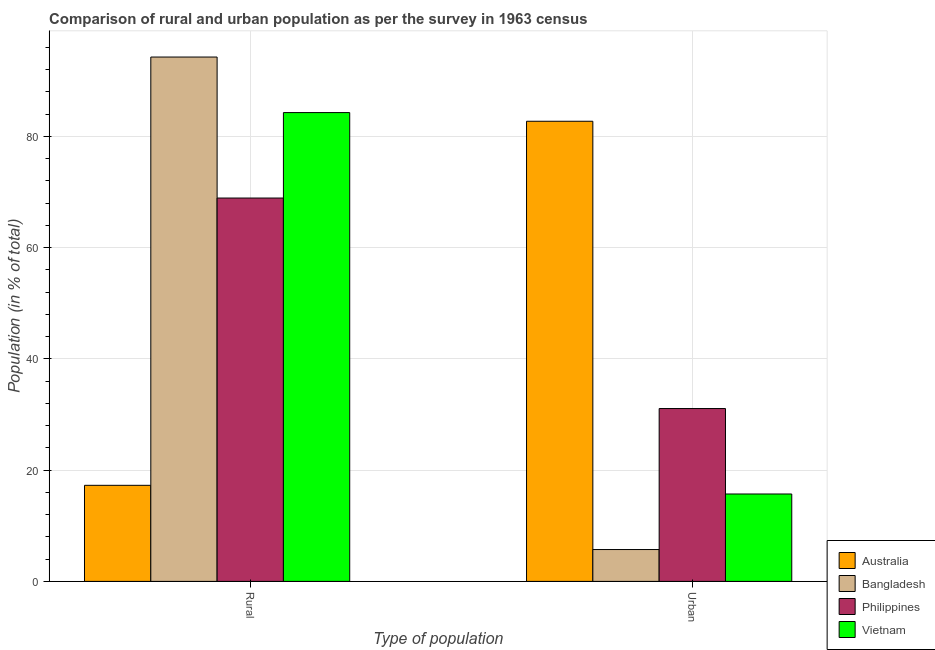How many groups of bars are there?
Your answer should be very brief. 2. Are the number of bars per tick equal to the number of legend labels?
Give a very brief answer. Yes. What is the label of the 2nd group of bars from the left?
Provide a short and direct response. Urban. What is the urban population in Australia?
Offer a terse response. 82.73. Across all countries, what is the maximum rural population?
Make the answer very short. 94.27. Across all countries, what is the minimum rural population?
Provide a short and direct response. 17.27. In which country was the rural population maximum?
Make the answer very short. Bangladesh. What is the total rural population in the graph?
Provide a succinct answer. 264.75. What is the difference between the urban population in Bangladesh and that in Vietnam?
Keep it short and to the point. -9.99. What is the difference between the urban population in Australia and the rural population in Vietnam?
Your answer should be compact. -1.56. What is the average urban population per country?
Provide a succinct answer. 33.81. What is the difference between the rural population and urban population in Bangladesh?
Your answer should be very brief. 88.55. What is the ratio of the urban population in Australia to that in Philippines?
Offer a very short reply. 2.66. What does the 4th bar from the left in Rural represents?
Provide a succinct answer. Vietnam. Are all the bars in the graph horizontal?
Keep it short and to the point. No. What is the difference between two consecutive major ticks on the Y-axis?
Offer a terse response. 20. Are the values on the major ticks of Y-axis written in scientific E-notation?
Provide a short and direct response. No. Does the graph contain grids?
Give a very brief answer. Yes. What is the title of the graph?
Make the answer very short. Comparison of rural and urban population as per the survey in 1963 census. Does "High income: nonOECD" appear as one of the legend labels in the graph?
Keep it short and to the point. No. What is the label or title of the X-axis?
Your answer should be compact. Type of population. What is the label or title of the Y-axis?
Your answer should be very brief. Population (in % of total). What is the Population (in % of total) of Australia in Rural?
Make the answer very short. 17.27. What is the Population (in % of total) in Bangladesh in Rural?
Make the answer very short. 94.27. What is the Population (in % of total) of Philippines in Rural?
Keep it short and to the point. 68.92. What is the Population (in % of total) of Vietnam in Rural?
Offer a terse response. 84.29. What is the Population (in % of total) of Australia in Urban?
Your response must be concise. 82.73. What is the Population (in % of total) of Bangladesh in Urban?
Keep it short and to the point. 5.73. What is the Population (in % of total) of Philippines in Urban?
Keep it short and to the point. 31.08. What is the Population (in % of total) in Vietnam in Urban?
Offer a terse response. 15.71. Across all Type of population, what is the maximum Population (in % of total) in Australia?
Make the answer very short. 82.73. Across all Type of population, what is the maximum Population (in % of total) of Bangladesh?
Ensure brevity in your answer.  94.27. Across all Type of population, what is the maximum Population (in % of total) in Philippines?
Offer a very short reply. 68.92. Across all Type of population, what is the maximum Population (in % of total) in Vietnam?
Ensure brevity in your answer.  84.29. Across all Type of population, what is the minimum Population (in % of total) in Australia?
Keep it short and to the point. 17.27. Across all Type of population, what is the minimum Population (in % of total) in Bangladesh?
Ensure brevity in your answer.  5.73. Across all Type of population, what is the minimum Population (in % of total) in Philippines?
Offer a terse response. 31.08. Across all Type of population, what is the minimum Population (in % of total) in Vietnam?
Keep it short and to the point. 15.71. What is the total Population (in % of total) of Philippines in the graph?
Your answer should be very brief. 100. What is the total Population (in % of total) of Vietnam in the graph?
Offer a very short reply. 100. What is the difference between the Population (in % of total) of Australia in Rural and that in Urban?
Give a very brief answer. -65.45. What is the difference between the Population (in % of total) of Bangladesh in Rural and that in Urban?
Provide a succinct answer. 88.55. What is the difference between the Population (in % of total) of Philippines in Rural and that in Urban?
Your answer should be very brief. 37.85. What is the difference between the Population (in % of total) in Vietnam in Rural and that in Urban?
Ensure brevity in your answer.  68.57. What is the difference between the Population (in % of total) in Australia in Rural and the Population (in % of total) in Bangladesh in Urban?
Your response must be concise. 11.55. What is the difference between the Population (in % of total) of Australia in Rural and the Population (in % of total) of Philippines in Urban?
Your response must be concise. -13.8. What is the difference between the Population (in % of total) of Australia in Rural and the Population (in % of total) of Vietnam in Urban?
Your answer should be compact. 1.56. What is the difference between the Population (in % of total) in Bangladesh in Rural and the Population (in % of total) in Philippines in Urban?
Offer a very short reply. 63.2. What is the difference between the Population (in % of total) in Bangladesh in Rural and the Population (in % of total) in Vietnam in Urban?
Provide a short and direct response. 78.56. What is the difference between the Population (in % of total) in Philippines in Rural and the Population (in % of total) in Vietnam in Urban?
Offer a terse response. 53.21. What is the average Population (in % of total) of Australia per Type of population?
Offer a terse response. 50. What is the average Population (in % of total) of Philippines per Type of population?
Your answer should be compact. 50. What is the average Population (in % of total) in Vietnam per Type of population?
Give a very brief answer. 50. What is the difference between the Population (in % of total) in Australia and Population (in % of total) in Bangladesh in Rural?
Your response must be concise. -77. What is the difference between the Population (in % of total) in Australia and Population (in % of total) in Philippines in Rural?
Your answer should be very brief. -51.65. What is the difference between the Population (in % of total) of Australia and Population (in % of total) of Vietnam in Rural?
Offer a terse response. -67.01. What is the difference between the Population (in % of total) in Bangladesh and Population (in % of total) in Philippines in Rural?
Give a very brief answer. 25.35. What is the difference between the Population (in % of total) in Bangladesh and Population (in % of total) in Vietnam in Rural?
Your answer should be very brief. 9.99. What is the difference between the Population (in % of total) in Philippines and Population (in % of total) in Vietnam in Rural?
Ensure brevity in your answer.  -15.36. What is the difference between the Population (in % of total) in Australia and Population (in % of total) in Philippines in Urban?
Provide a succinct answer. 51.65. What is the difference between the Population (in % of total) in Australia and Population (in % of total) in Vietnam in Urban?
Your answer should be compact. 67.01. What is the difference between the Population (in % of total) in Bangladesh and Population (in % of total) in Philippines in Urban?
Provide a succinct answer. -25.35. What is the difference between the Population (in % of total) in Bangladesh and Population (in % of total) in Vietnam in Urban?
Give a very brief answer. -9.99. What is the difference between the Population (in % of total) in Philippines and Population (in % of total) in Vietnam in Urban?
Ensure brevity in your answer.  15.36. What is the ratio of the Population (in % of total) of Australia in Rural to that in Urban?
Offer a terse response. 0.21. What is the ratio of the Population (in % of total) in Bangladesh in Rural to that in Urban?
Your answer should be very brief. 16.46. What is the ratio of the Population (in % of total) of Philippines in Rural to that in Urban?
Keep it short and to the point. 2.22. What is the ratio of the Population (in % of total) in Vietnam in Rural to that in Urban?
Your answer should be very brief. 5.36. What is the difference between the highest and the second highest Population (in % of total) of Australia?
Give a very brief answer. 65.45. What is the difference between the highest and the second highest Population (in % of total) in Bangladesh?
Offer a terse response. 88.55. What is the difference between the highest and the second highest Population (in % of total) of Philippines?
Make the answer very short. 37.85. What is the difference between the highest and the second highest Population (in % of total) of Vietnam?
Ensure brevity in your answer.  68.57. What is the difference between the highest and the lowest Population (in % of total) of Australia?
Your response must be concise. 65.45. What is the difference between the highest and the lowest Population (in % of total) in Bangladesh?
Make the answer very short. 88.55. What is the difference between the highest and the lowest Population (in % of total) of Philippines?
Provide a short and direct response. 37.85. What is the difference between the highest and the lowest Population (in % of total) of Vietnam?
Your response must be concise. 68.57. 